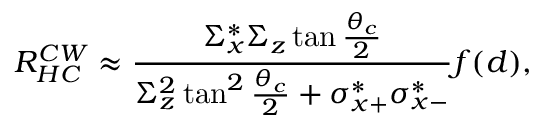<formula> <loc_0><loc_0><loc_500><loc_500>R _ { H C } ^ { C W } \approx \frac { \Sigma _ { x } ^ { * } \Sigma _ { z } \tan \frac { \theta _ { c } } { 2 } } { \Sigma _ { z } ^ { 2 } \tan ^ { 2 } \frac { \theta _ { c } } { 2 } + \sigma _ { x + } ^ { * } \sigma _ { x - } ^ { * } } f ( d ) ,</formula> 